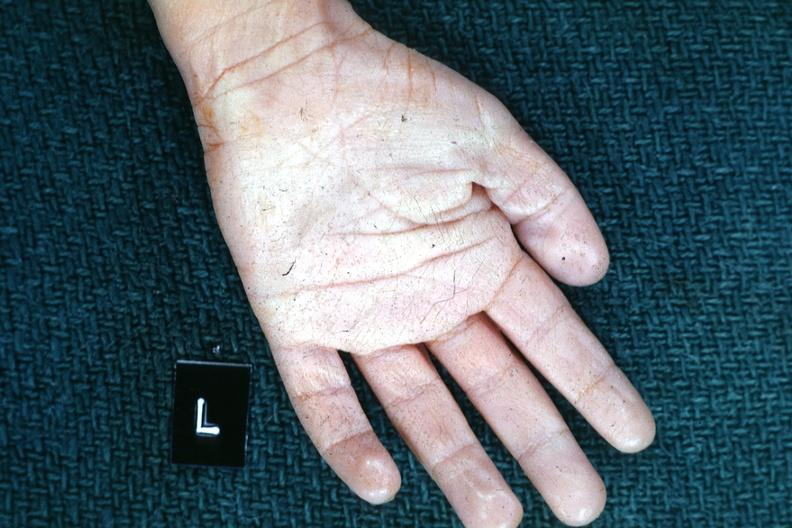re extremities present?
Answer the question using a single word or phrase. Yes 